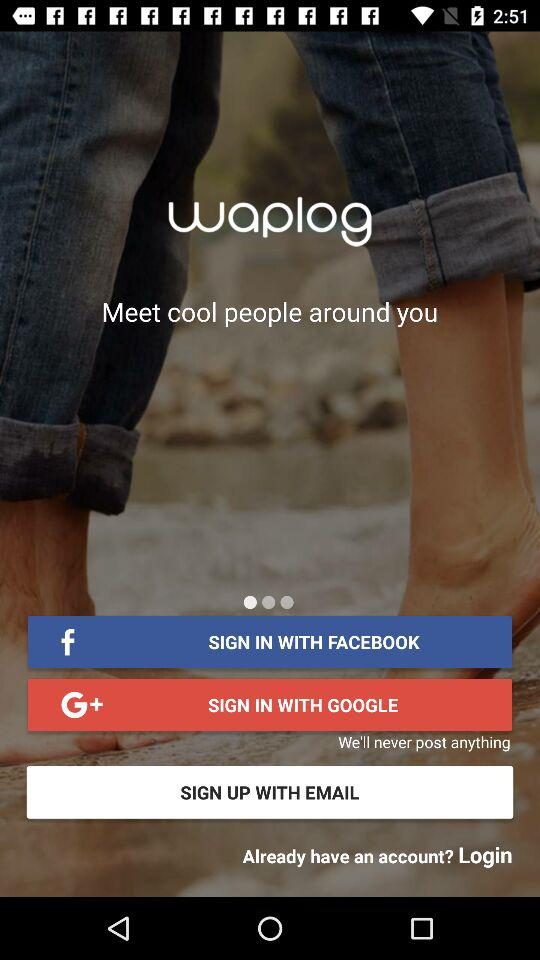What is the name of the application? The name of the application is "waplog". 